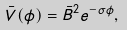<formula> <loc_0><loc_0><loc_500><loc_500>\bar { V } ( \phi ) = \bar { B } ^ { 2 } e ^ { - \sigma \phi } ,</formula> 